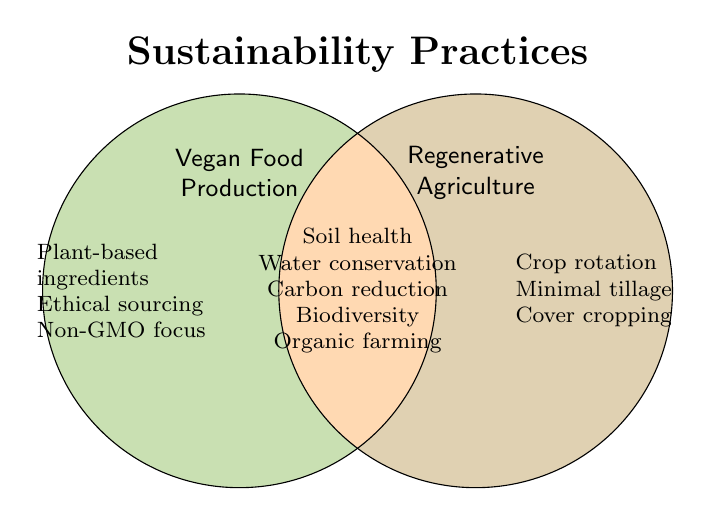Which practices are unique to regenerative agriculture? The practices unique to regenerative agriculture listed in the figure are "Crop rotation," "Minimal tillage," and "Cover cropping."
Answer: Crop rotation, Minimal tillage, Cover cropping Which sustainability practices are common to both vegan food production and regenerative agriculture? The practices common to both are "Soil health improvement," "Water conservation," "Reduced carbon footprint," "Biodiversity promotion," and "Organic farming methods."
Answer: Soil health improvement, Water conservation, Reduced carbon footprint, Biodiversity promotion, Organic farming methods How many total practices are listed in the figure? The figure lists 3 practices unique to vegan food production, 3 unique to regenerative agriculture, and 5 that are common to both. Summing these gives a total of 3 + 3 + 5 = 11 practices.
Answer: 11 Which category has the most unique practices? Vegan food production has 3 unique practices, and regenerative agriculture also has 3 unique practices. Both categories have an equal number of unique practices.
Answer: Both What is the title of the figure? The title of the figure is "Sustainability Practices."
Answer: Sustainability Practices Which practices are related to soil health? According to the figure, "Soil health improvement" is common to both vegan food production and regenerative agriculture.
Answer: Soil health improvement Are ethical sourcing and cover cropping practiced together in any category? Ethical sourcing is a practice in vegan food production, while cover cropping is a practice in regenerative agriculture. They are not listed as overlapping practices.
Answer: No What colors represent vegan food production and regenerative agriculture in the figure? Vegan food production is represented by a green color, and regenerative agriculture is represented by a brown color.
Answer: Green and Brown Which practices are unique to vegan food production? The practices unique to vegan food production listed in the figure are "Plant-based ingredients," "Ethical sourcing," and "Non-GMO focus."
Answer: Plant-based ingredients, Ethical sourcing, Non-GMO focus 